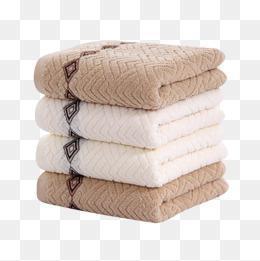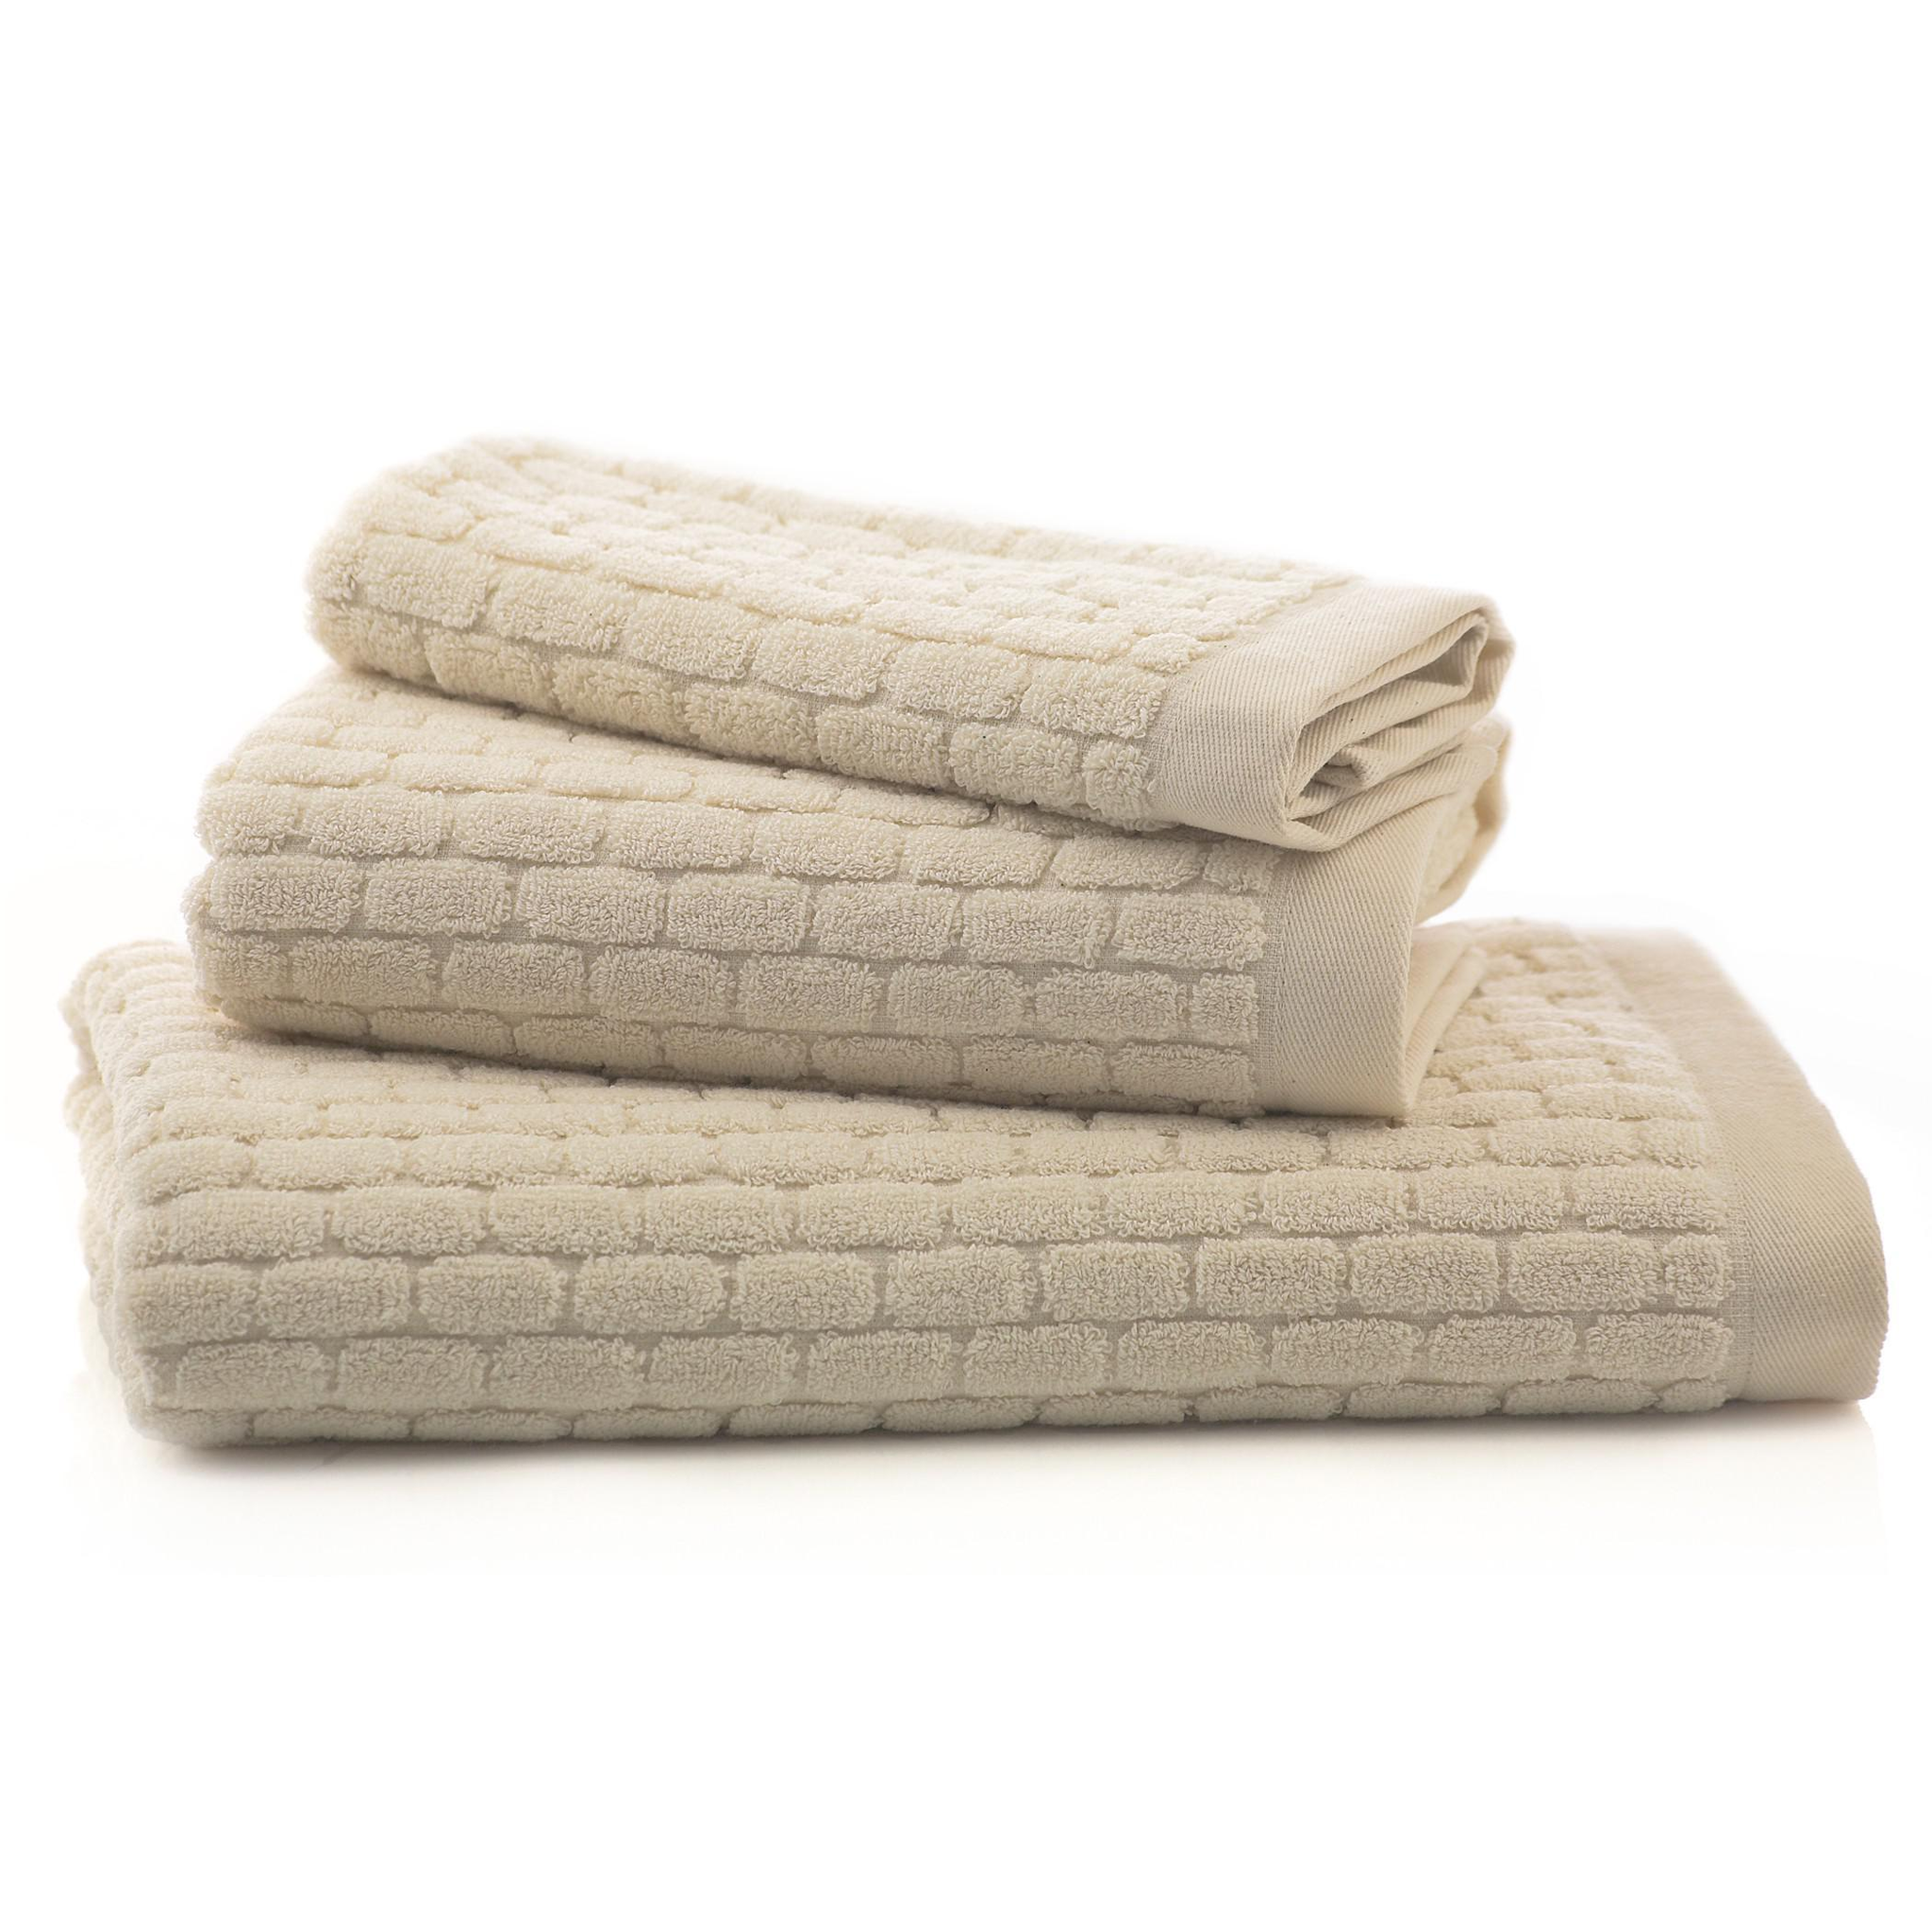The first image is the image on the left, the second image is the image on the right. Evaluate the accuracy of this statement regarding the images: "Each image contains different towel sizes, and at least one image shows at least three different towel sizes in one stack.". Is it true? Answer yes or no. No. The first image is the image on the left, the second image is the image on the right. For the images shown, is this caption "There are 4 bath-towels of equal size stacked on top of each other" true? Answer yes or no. Yes. 